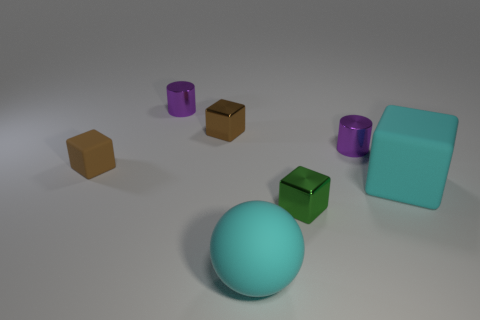Subtract all brown shiny cubes. How many cubes are left? 3 Subtract all red cylinders. How many brown blocks are left? 2 Add 3 blue cylinders. How many objects exist? 10 Subtract 1 blocks. How many blocks are left? 3 Subtract all balls. How many objects are left? 6 Add 4 large rubber balls. How many large rubber balls exist? 5 Subtract all cyan blocks. How many blocks are left? 3 Subtract 0 cyan cylinders. How many objects are left? 7 Subtract all red balls. Subtract all red cylinders. How many balls are left? 1 Subtract all purple cylinders. Subtract all brown shiny objects. How many objects are left? 4 